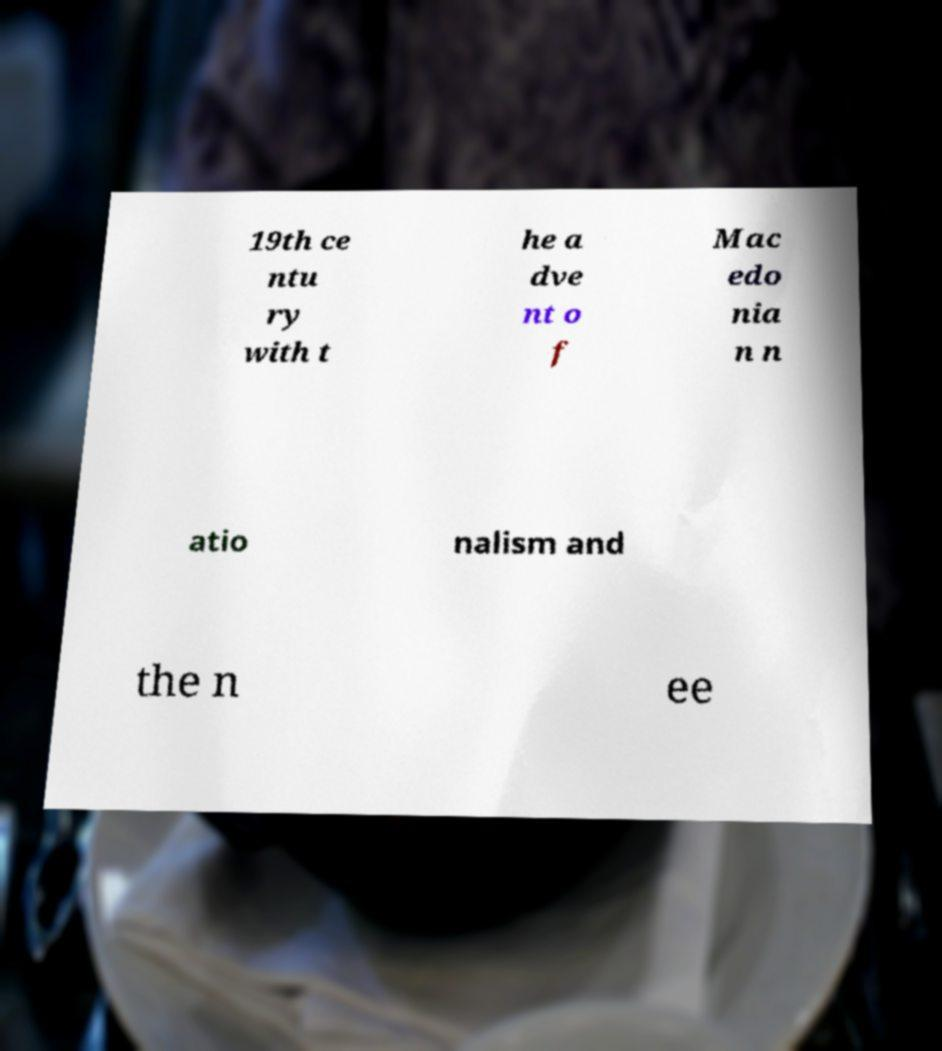Please read and relay the text visible in this image. What does it say? 19th ce ntu ry with t he a dve nt o f Mac edo nia n n atio nalism and the n ee 